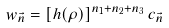<formula> <loc_0><loc_0><loc_500><loc_500>w _ { \vec { n } } = [ h ( \rho ) ] ^ { n _ { 1 } + n _ { 2 } + n _ { 3 } } \, c _ { \vec { n } }</formula> 